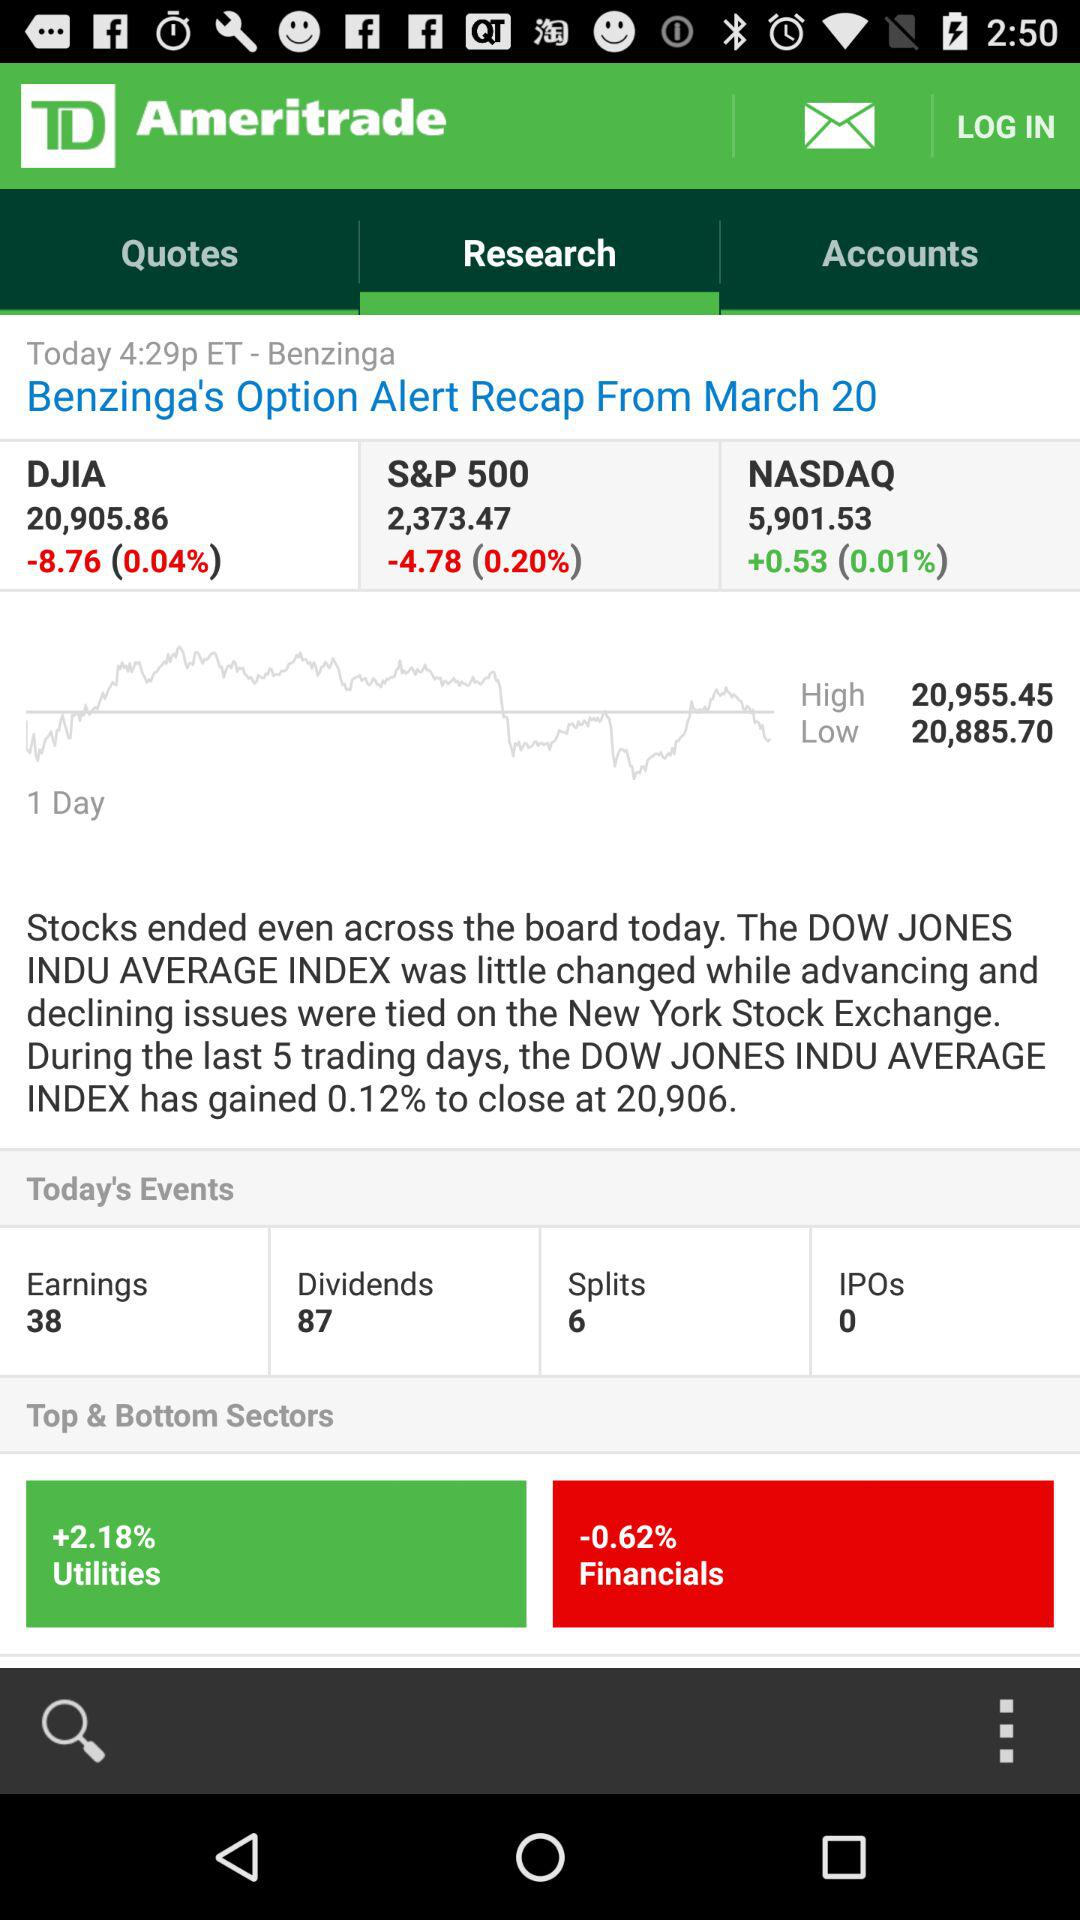Which sector has the highest percentage gain?
Answer the question using a single word or phrase. Utilities 